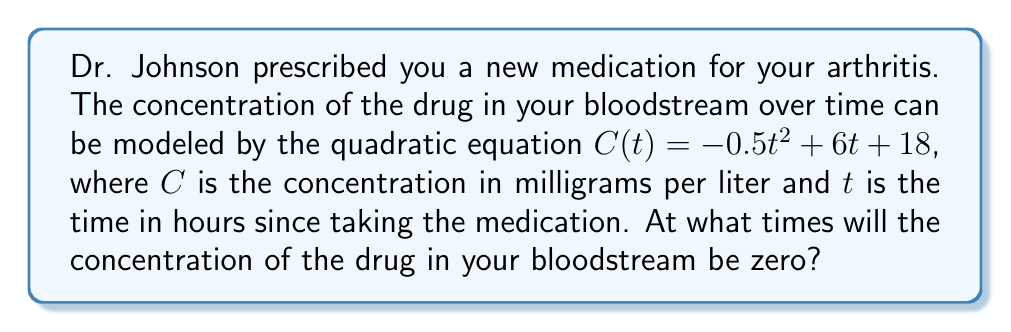Provide a solution to this math problem. To find the times when the concentration of the drug will be zero, we need to solve the quadratic equation:

$C(t) = -0.5t^2 + 6t + 18 = 0$

We can solve this using the quadratic formula: $t = \frac{-b \pm \sqrt{b^2 - 4ac}}{2a}$

Where $a = -0.5$, $b = 6$, and $c = 18$

Let's substitute these values:

$t = \frac{-6 \pm \sqrt{6^2 - 4(-0.5)(18)}}{2(-0.5)}$

$t = \frac{-6 \pm \sqrt{36 + 36}}{-1}$

$t = \frac{-6 \pm \sqrt{72}}{-1}$

$t = \frac{-6 \pm 6\sqrt{2}}{-1}$

Simplifying:

$t = 6 \mp 6\sqrt{2}$

This gives us two solutions:

$t_1 = 6 + 6\sqrt{2}$ and $t_2 = 6 - 6\sqrt{2}$

However, since time cannot be negative in this context, we need to check if both solutions are positive.

$t_1 = 6 + 6\sqrt{2} \approx 14.49$ hours (positive)
$t_2 = 6 - 6\sqrt{2} \approx -2.49$ hours (negative)

Therefore, we only consider the positive solution.
Answer: The concentration of the drug in your bloodstream will be zero after approximately 14.49 hours, or more precisely, at $t = 6 + 6\sqrt{2}$ hours after taking the medication. 